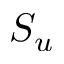<formula> <loc_0><loc_0><loc_500><loc_500>S _ { u }</formula> 